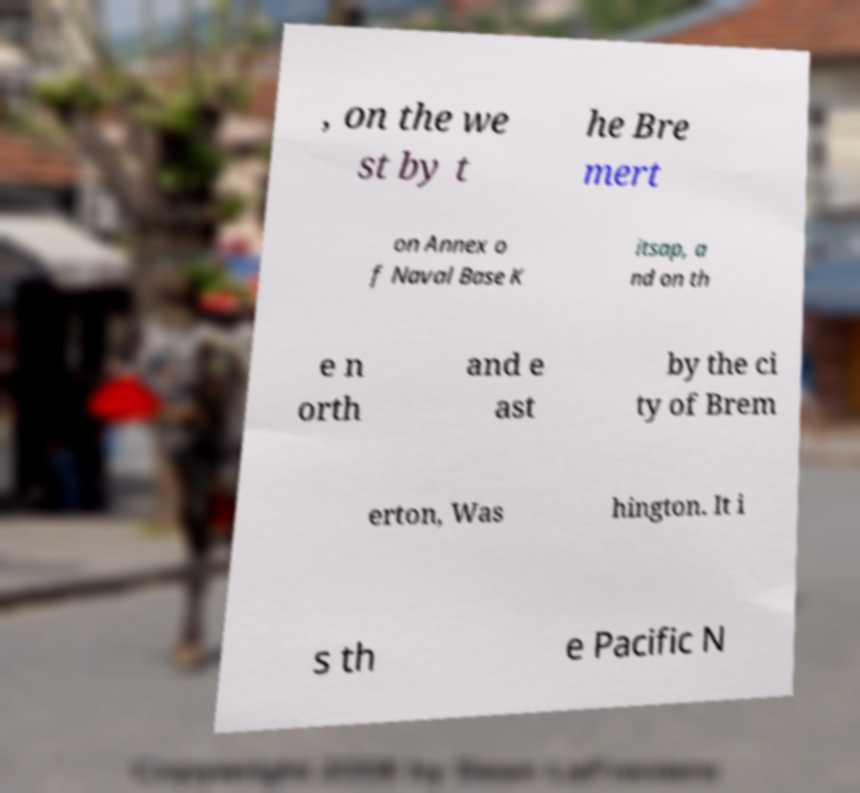Please read and relay the text visible in this image. What does it say? , on the we st by t he Bre mert on Annex o f Naval Base K itsap, a nd on th e n orth and e ast by the ci ty of Brem erton, Was hington. It i s th e Pacific N 